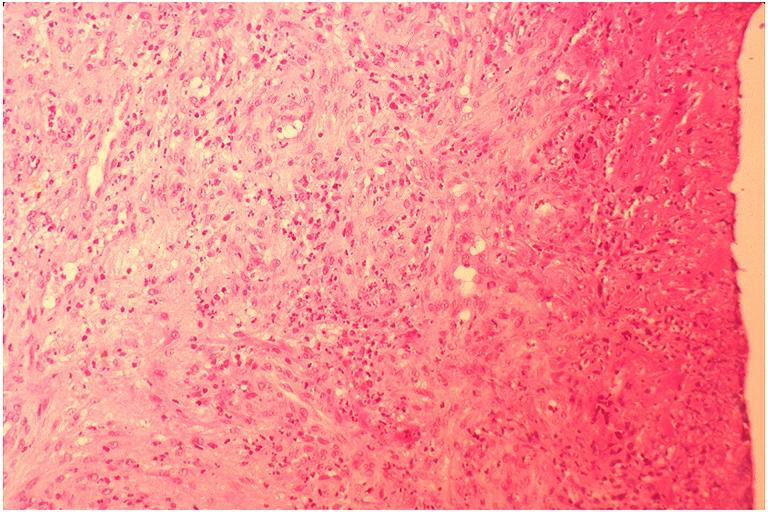where is this?
Answer the question using a single word or phrase. Oral 